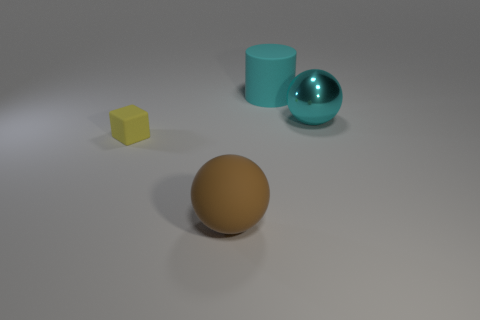Subtract all brown spheres. How many spheres are left? 1 Add 2 small metallic things. How many objects exist? 6 Subtract 1 cylinders. How many cylinders are left? 0 Subtract 0 red cylinders. How many objects are left? 4 Subtract all cylinders. How many objects are left? 3 Subtract all yellow spheres. Subtract all gray cylinders. How many spheres are left? 2 Subtract all red cylinders. How many brown cubes are left? 0 Subtract all large gray things. Subtract all brown things. How many objects are left? 3 Add 3 brown balls. How many brown balls are left? 4 Add 4 brown objects. How many brown objects exist? 5 